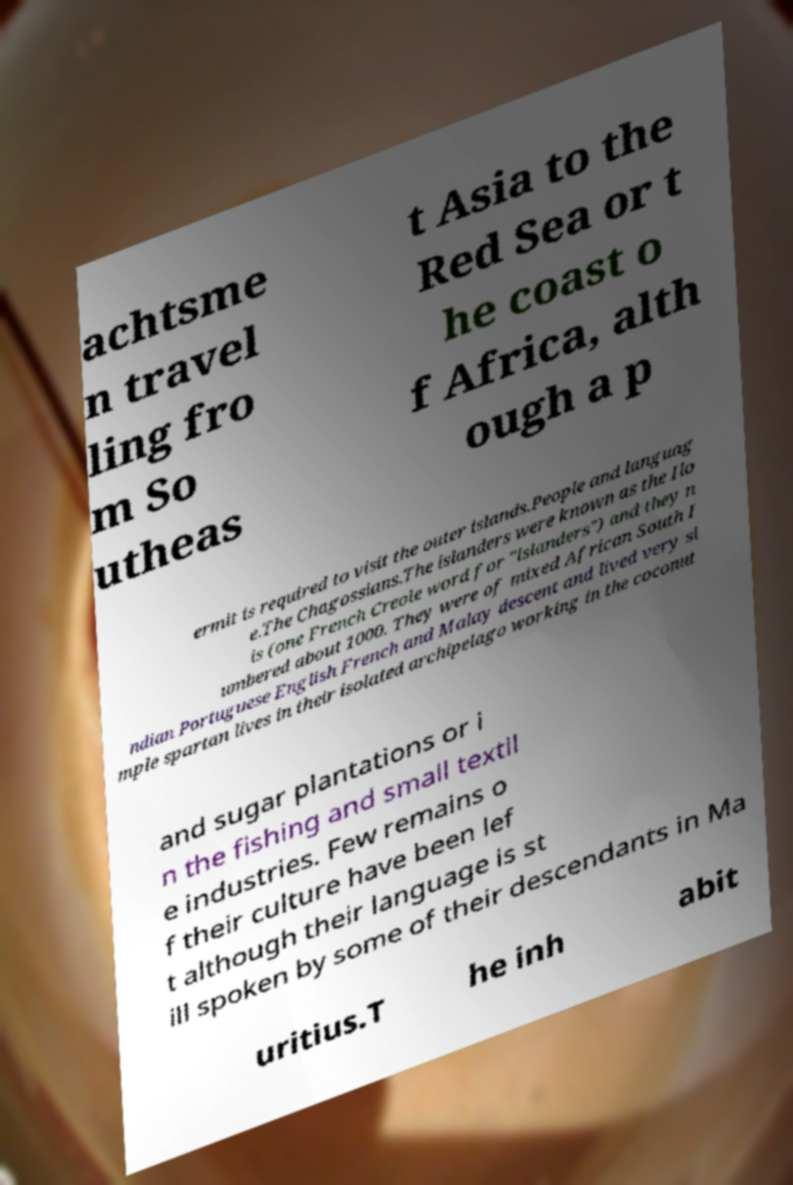Can you read and provide the text displayed in the image?This photo seems to have some interesting text. Can you extract and type it out for me? achtsme n travel ling fro m So utheas t Asia to the Red Sea or t he coast o f Africa, alth ough a p ermit is required to visit the outer islands.People and languag e.The Chagossians.The islanders were known as the Ilo is (one French Creole word for "islanders") and they n umbered about 1000. They were of mixed African South I ndian Portuguese English French and Malay descent and lived very si mple spartan lives in their isolated archipelago working in the coconut and sugar plantations or i n the fishing and small textil e industries. Few remains o f their culture have been lef t although their language is st ill spoken by some of their descendants in Ma uritius.T he inh abit 